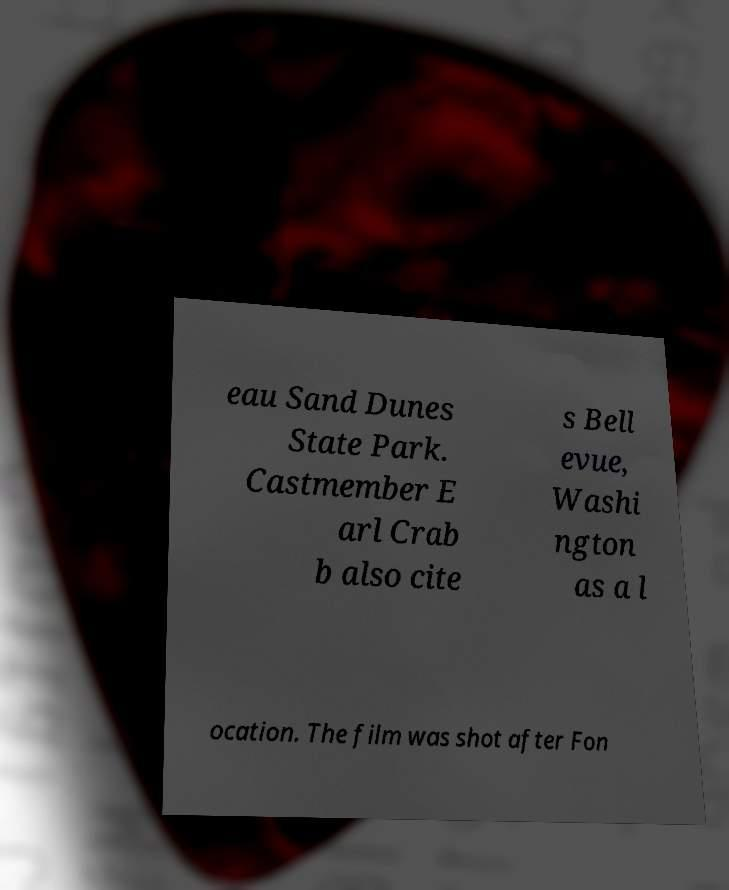Could you assist in decoding the text presented in this image and type it out clearly? eau Sand Dunes State Park. Castmember E arl Crab b also cite s Bell evue, Washi ngton as a l ocation. The film was shot after Fon 